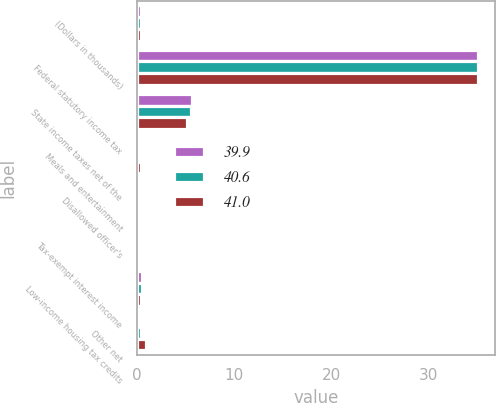Convert chart. <chart><loc_0><loc_0><loc_500><loc_500><stacked_bar_chart><ecel><fcel>(Dollars in thousands)<fcel>Federal statutory income tax<fcel>State income taxes net of the<fcel>Meals and entertainment<fcel>Disallowed officer's<fcel>Tax-exempt interest income<fcel>Low-income housing tax credits<fcel>Other net<nl><fcel>39.9<fcel>0.4<fcel>35<fcel>5.7<fcel>0.3<fcel>0.3<fcel>0.2<fcel>0.5<fcel>0.3<nl><fcel>40.6<fcel>0.4<fcel>35<fcel>5.6<fcel>0.3<fcel>0.3<fcel>0.3<fcel>0.5<fcel>0.4<nl><fcel>41<fcel>0.4<fcel>35<fcel>5.2<fcel>0.4<fcel>0.1<fcel>0.3<fcel>0.4<fcel>0.9<nl></chart> 